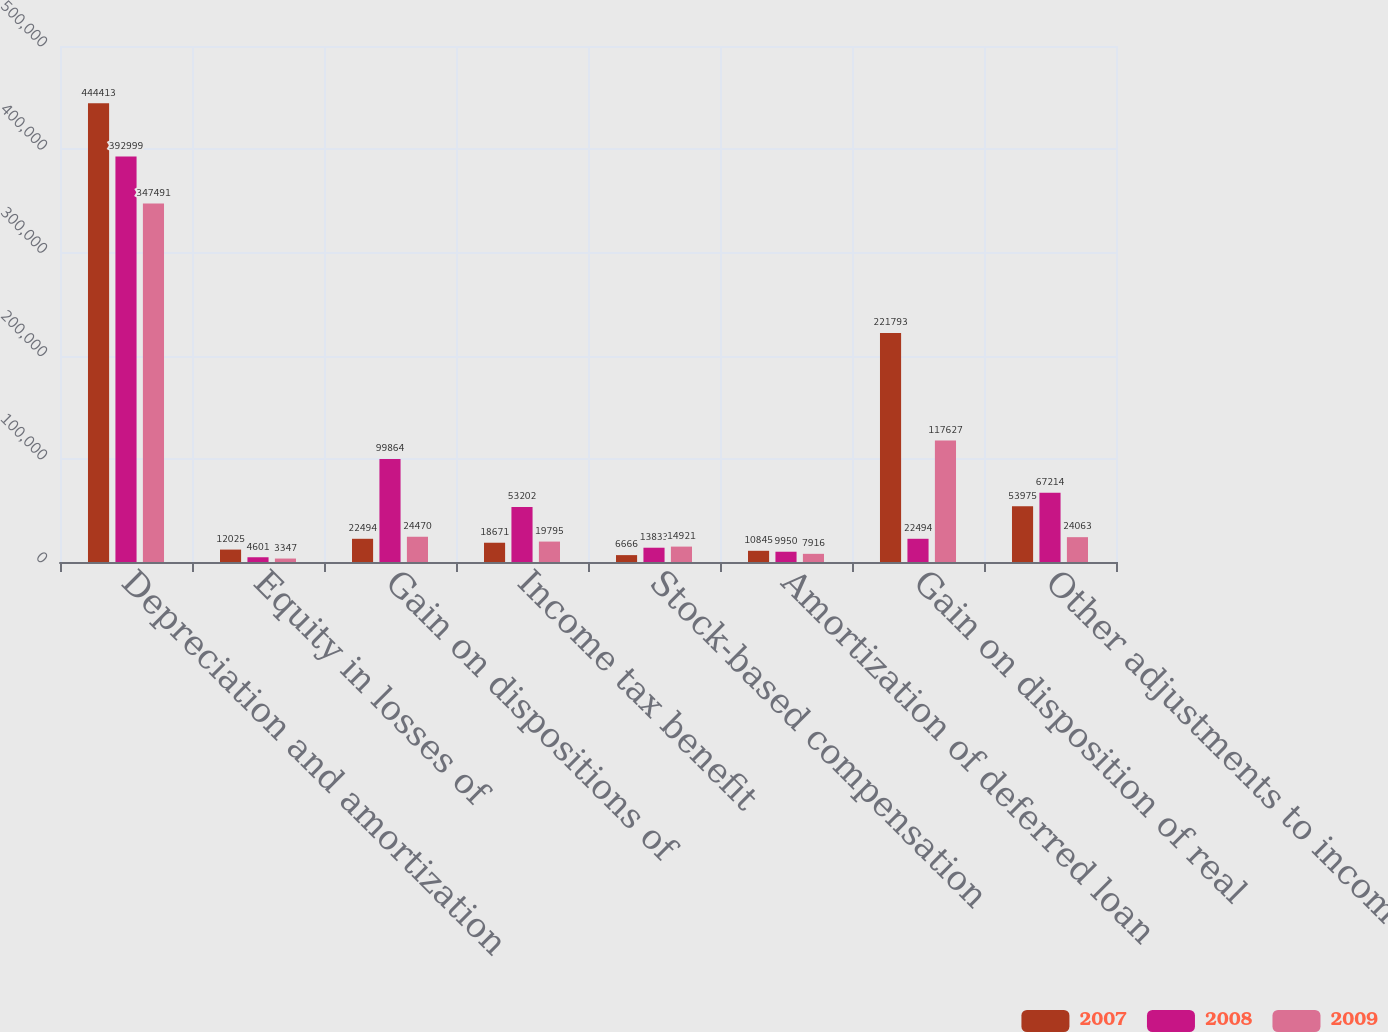Convert chart to OTSL. <chart><loc_0><loc_0><loc_500><loc_500><stacked_bar_chart><ecel><fcel>Depreciation and amortization<fcel>Equity in losses of<fcel>Gain on dispositions of<fcel>Income tax benefit<fcel>Stock-based compensation<fcel>Amortization of deferred loan<fcel>Gain on disposition of real<fcel>Other adjustments to income<nl><fcel>2007<fcel>444413<fcel>12025<fcel>22494<fcel>18671<fcel>6666<fcel>10845<fcel>221793<fcel>53975<nl><fcel>2008<fcel>392999<fcel>4601<fcel>99864<fcel>53202<fcel>13833<fcel>9950<fcel>22494<fcel>67214<nl><fcel>2009<fcel>347491<fcel>3347<fcel>24470<fcel>19795<fcel>14921<fcel>7916<fcel>117627<fcel>24063<nl></chart> 